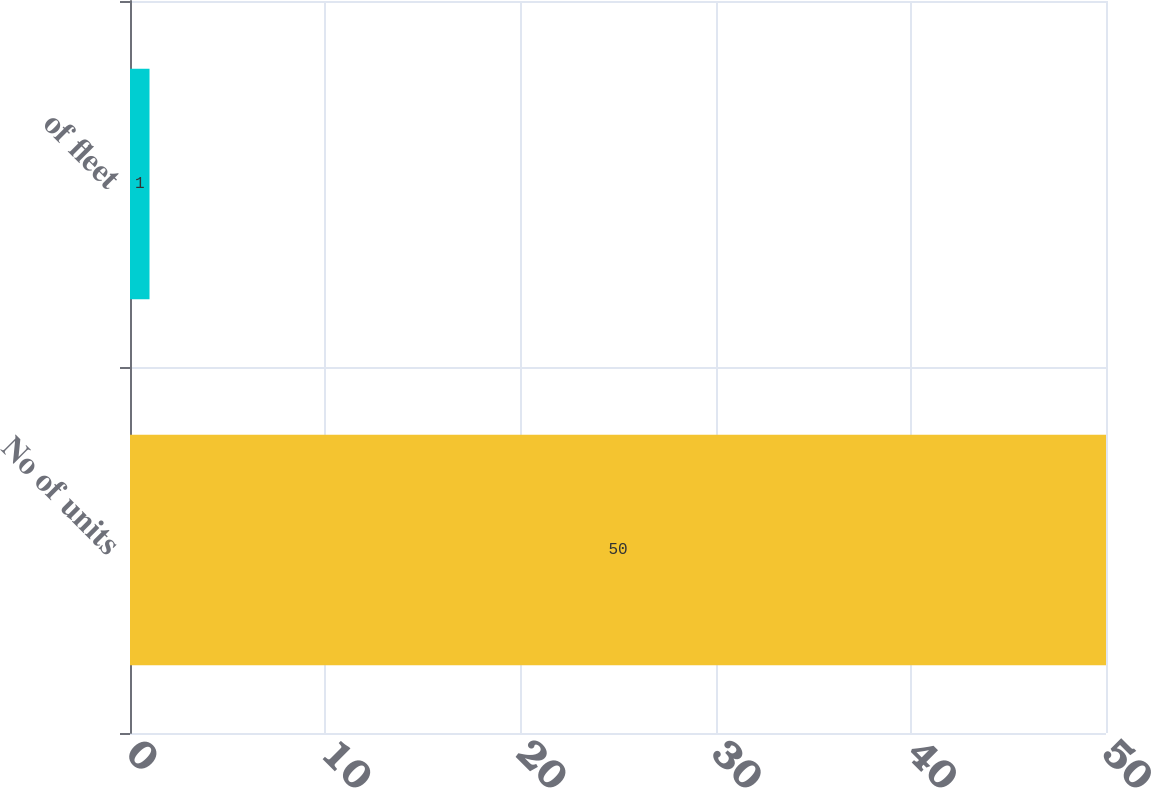Convert chart to OTSL. <chart><loc_0><loc_0><loc_500><loc_500><bar_chart><fcel>No of units<fcel>of fleet<nl><fcel>50<fcel>1<nl></chart> 